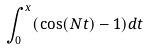<formula> <loc_0><loc_0><loc_500><loc_500>\int _ { 0 } ^ { x } ( \cos ( N t ) - 1 ) d t</formula> 